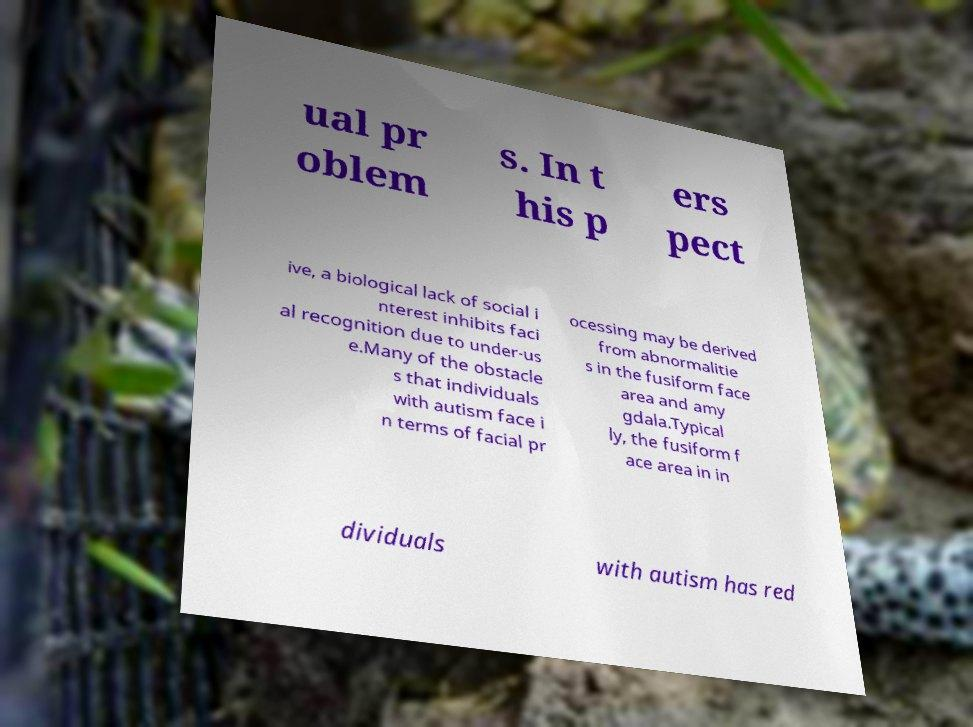I need the written content from this picture converted into text. Can you do that? ual pr oblem s. In t his p ers pect ive, a biological lack of social i nterest inhibits faci al recognition due to under-us e.Many of the obstacle s that individuals with autism face i n terms of facial pr ocessing may be derived from abnormalitie s in the fusiform face area and amy gdala.Typical ly, the fusiform f ace area in in dividuals with autism has red 